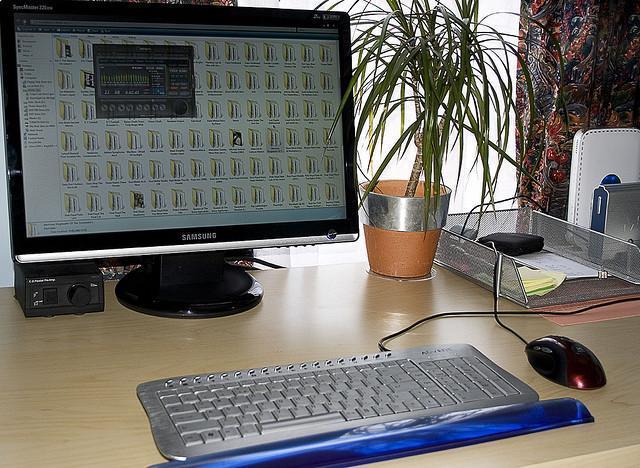How many men on this table closest to us?
Give a very brief answer. 0. 